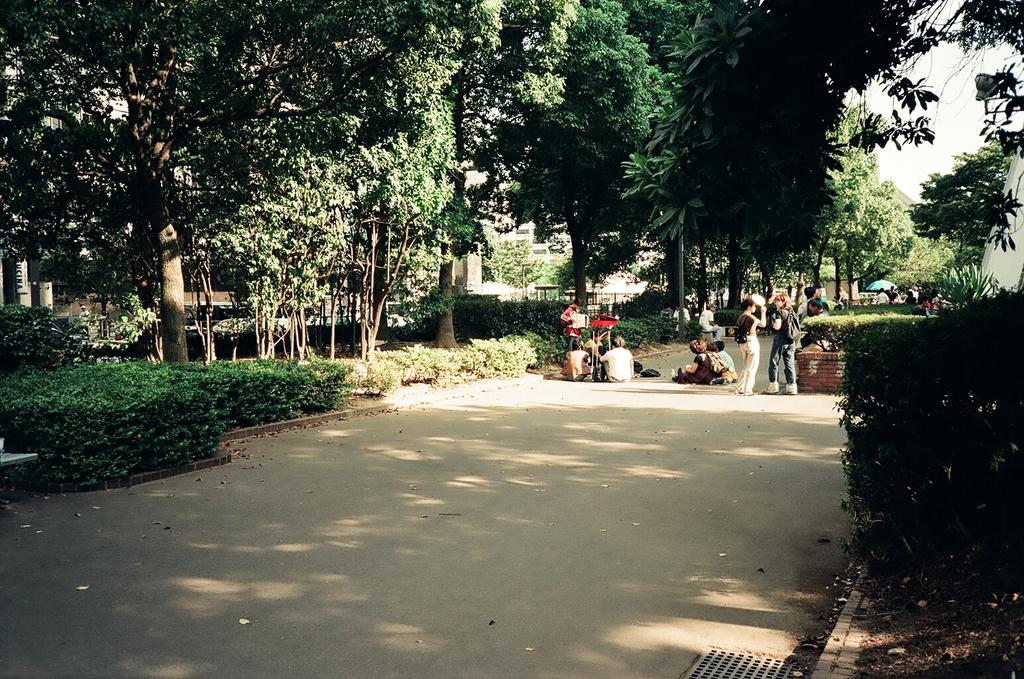What type of vegetation can be seen in the image? There is a group of trees and plants in the image. What is the position of the persons in the image? The persons are in front of the plants in the image. What structures are visible behind the trees? There are buildings behind the trees in the image. What part of the natural environment is visible in the image? The sky is visible in the top right corner of the image. What type of flower is being copied by the boat in the image? There is no flower or boat present in the image. 